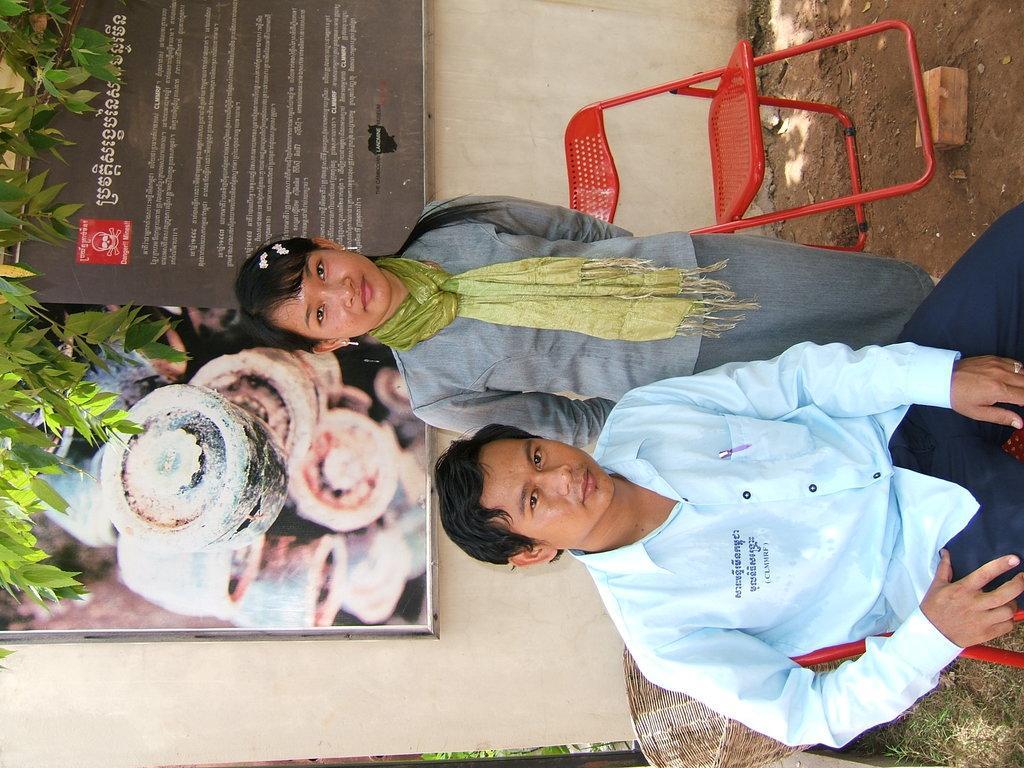Can you describe this image briefly? In this image we can see a man sitting on a chair. We can also see a woman standing beside him. On the backside we can see a chair, a wooden block and a basket placed on the ground. We can also see a tree and a board with some text on a wall. 